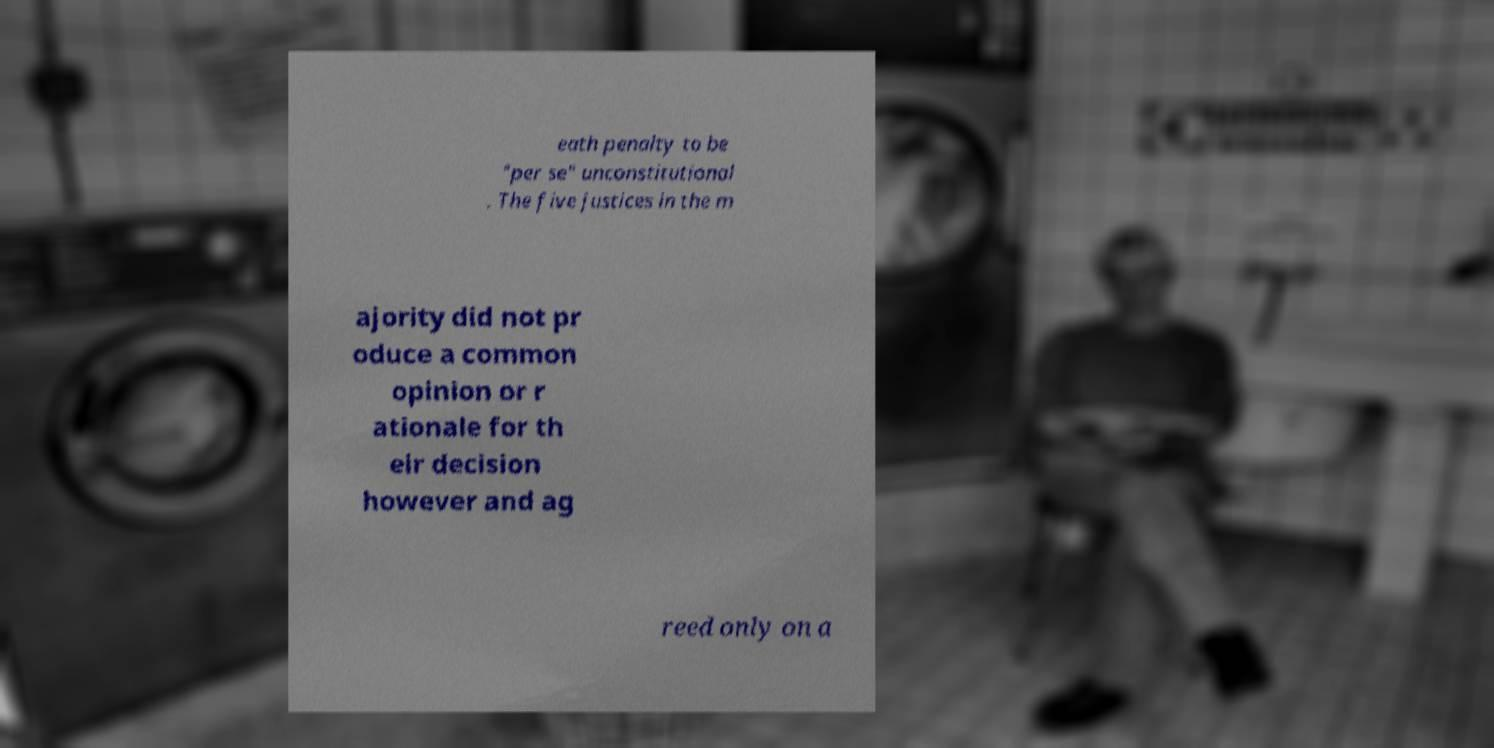I need the written content from this picture converted into text. Can you do that? eath penalty to be "per se" unconstitutional . The five justices in the m ajority did not pr oduce a common opinion or r ationale for th eir decision however and ag reed only on a 